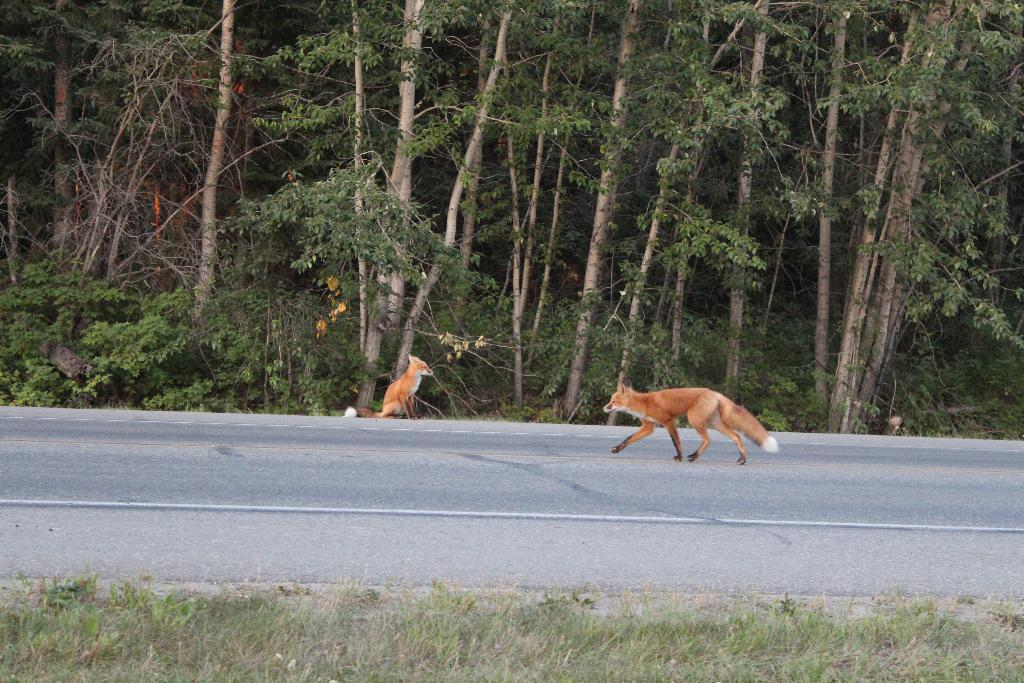How many animals are present in the image? There are two animals in the image. What is the color of the animals? The animals are brown in color. What can be seen in the background of the image? There are trees in the background of the image. What is the color of the trees? The trees are green in color. Do the animals have a tendency to wear trousers in the image? There is no indication in the image that the animals are wearing trousers or have any such tendency. 